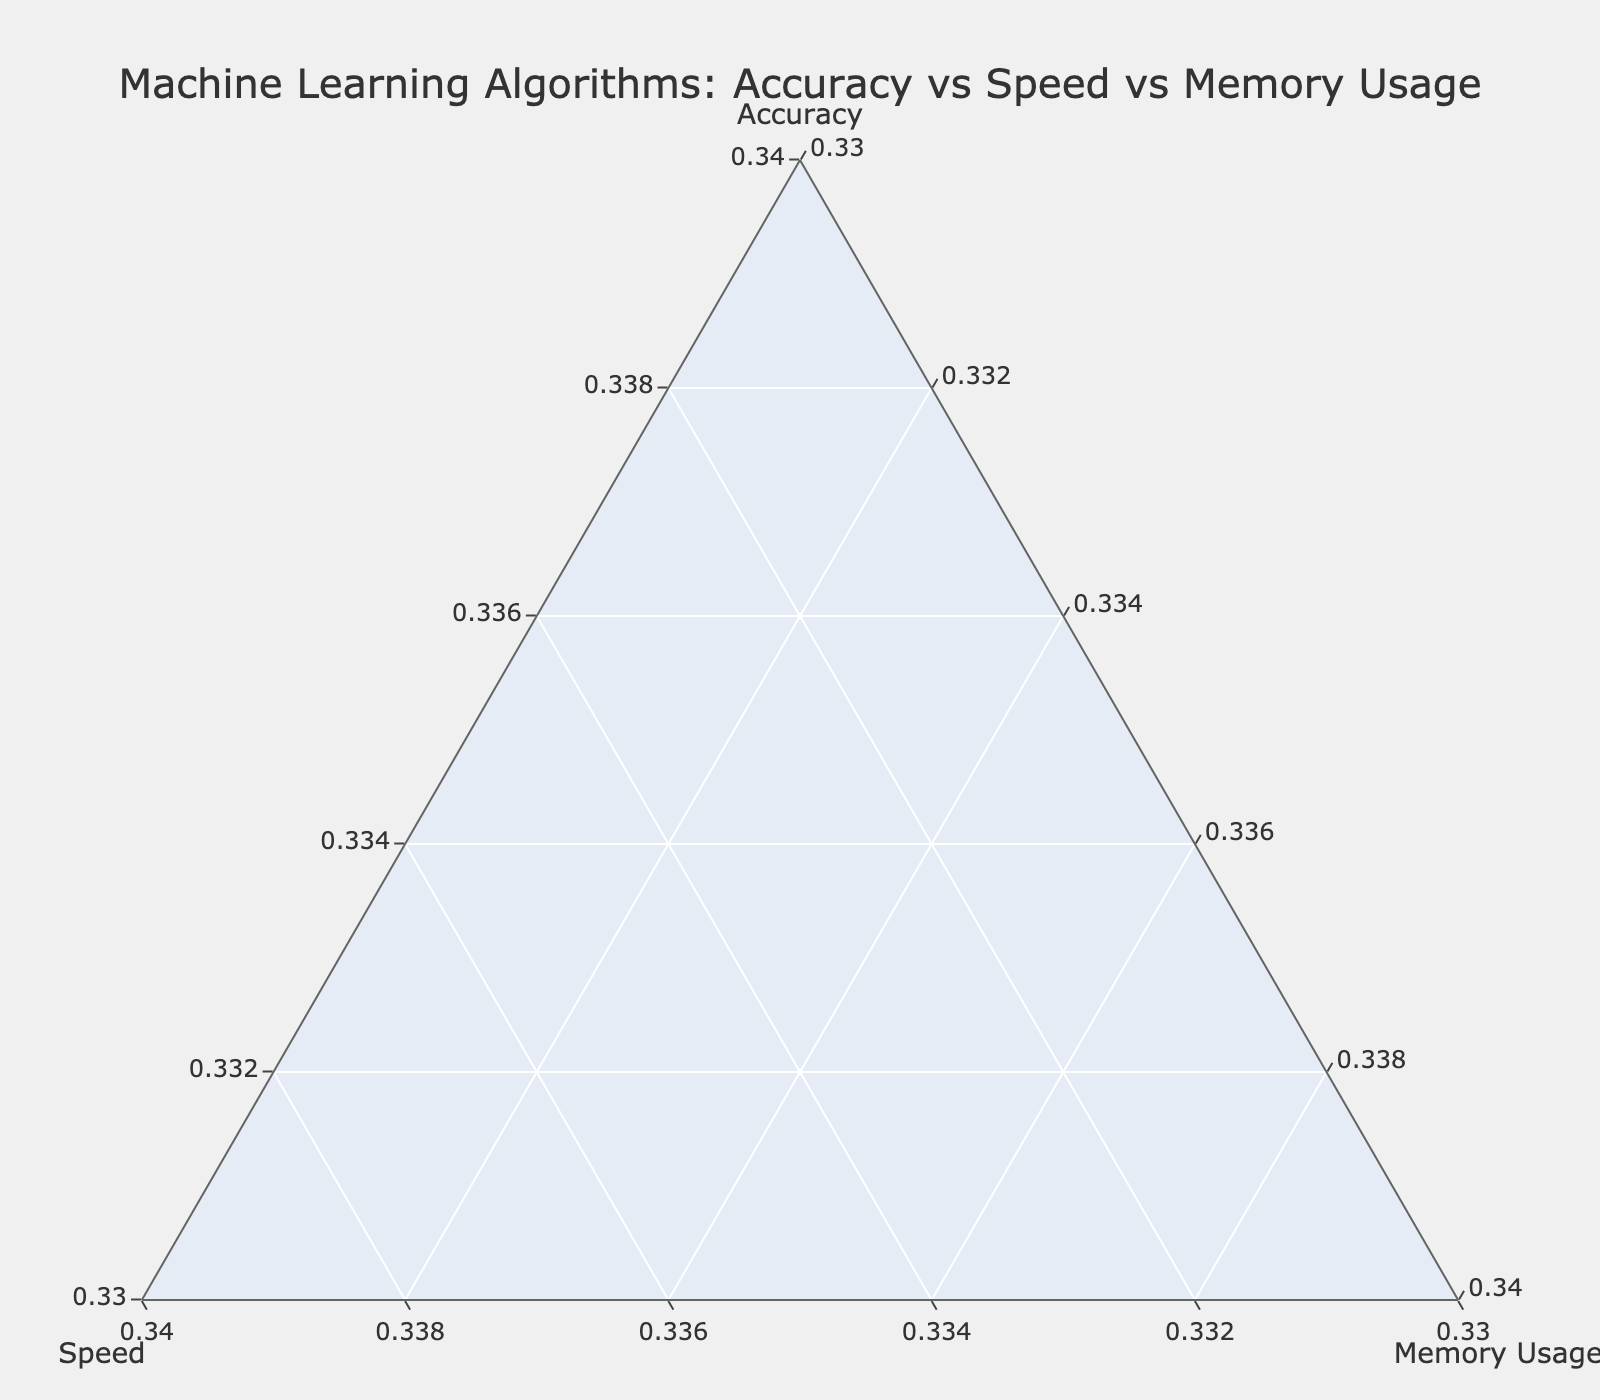How many algorithms are represented in the plot? Count the number of data points or labels associated with the algorithms.
Answer: 10 Which algorithm has the highest accuracy? Look for the label associated with the point closest to the 'Accuracy' axis.
Answer: Neural Network Which algorithms have the same memory usage? Identify algorithms with the same value in the 'Memory Usage' axis, observed as points at the same vertical level in the ternary plot.
Answer: Random Forest, Support Vector Machine, Gradient Boosting, Neural Network, XGBoost, AdaBoost Which algorithm is the fastest? Find the algorithm label at the point closest to the 'Speed' axis.
Answer: Naive Bayes List the algorithms and their positions with an equal contribution of accuracy, speed, and memory usage. Identify any points near the (0.33, 0.33, 0.33) equilibrium in the ternary plot where all three components contribute equally.
Answer: None Which algorithm has the highest accuracy and the highest memory usage? Find the algorithm point closest to the 'Accuracy' axis that also has a higher position in 'Memory Usage'.
Answer: Neural Network Which algorithm has a speed greater than its accuracy? Compare the 'Speed' and 'Accuracy' values of each algorithm, looking for points further along the 'Speed' axis than the 'Accuracy' axis.
Answer: Naive Bayes What is the average accuracy of the algorithms presented? Sum the accuracy values of all algorithms and divide by the number of algorithms: (0.65 + 0.55 + 0.60 + 0.45 + 0.70 + 0.50 + 0.40 + 0.45 + 0.65 + 0.55) / 10.
Answer: 0.55 Which two algorithms have identical coordinates in the plot? Look for any overlapping points in the ternary plot, which would imply identical values for Accuracy, Speed, and Memory Usage.
Answer: Random Forest and XGBoost 